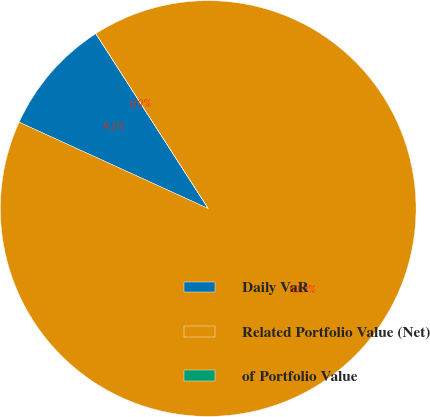<chart> <loc_0><loc_0><loc_500><loc_500><pie_chart><fcel>Daily VaR<fcel>Related Portfolio Value (Net)<fcel>of Portfolio Value<nl><fcel>9.09%<fcel>90.91%<fcel>0.0%<nl></chart> 